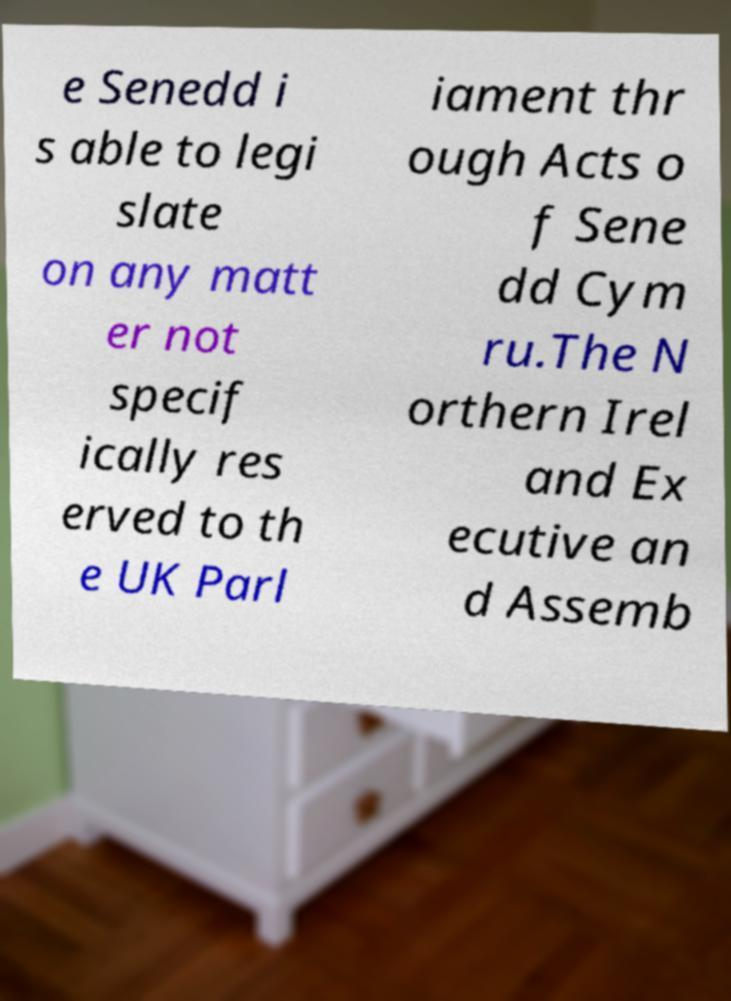Can you accurately transcribe the text from the provided image for me? e Senedd i s able to legi slate on any matt er not specif ically res erved to th e UK Parl iament thr ough Acts o f Sene dd Cym ru.The N orthern Irel and Ex ecutive an d Assemb 